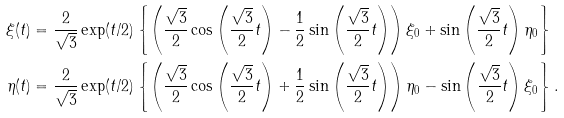Convert formula to latex. <formula><loc_0><loc_0><loc_500><loc_500>\xi ( t ) & = \frac { 2 } { \sqrt { 3 } } \exp ( t / 2 ) \left \{ \left ( \frac { \sqrt { 3 } } { 2 } \cos \left ( \frac { \sqrt { 3 } } { 2 } t \right ) - \frac { 1 } { 2 } \sin \left ( \frac { \sqrt { 3 } } { 2 } t \right ) \right ) \xi _ { 0 } + \sin \left ( \frac { \sqrt { 3 } } { 2 } t \right ) \eta _ { 0 } \right \} \\ \eta ( t ) & = \frac { 2 } { \sqrt { 3 } } \exp ( t / 2 ) \left \{ \left ( \frac { \sqrt { 3 } } { 2 } \cos \left ( \frac { \sqrt { 3 } } { 2 } t \right ) + \frac { 1 } { 2 } \sin \left ( \frac { \sqrt { 3 } } { 2 } t \right ) \right ) \eta _ { 0 } - \sin \left ( \frac { \sqrt { 3 } } { 2 } t \right ) \xi _ { 0 } \right \} .</formula> 